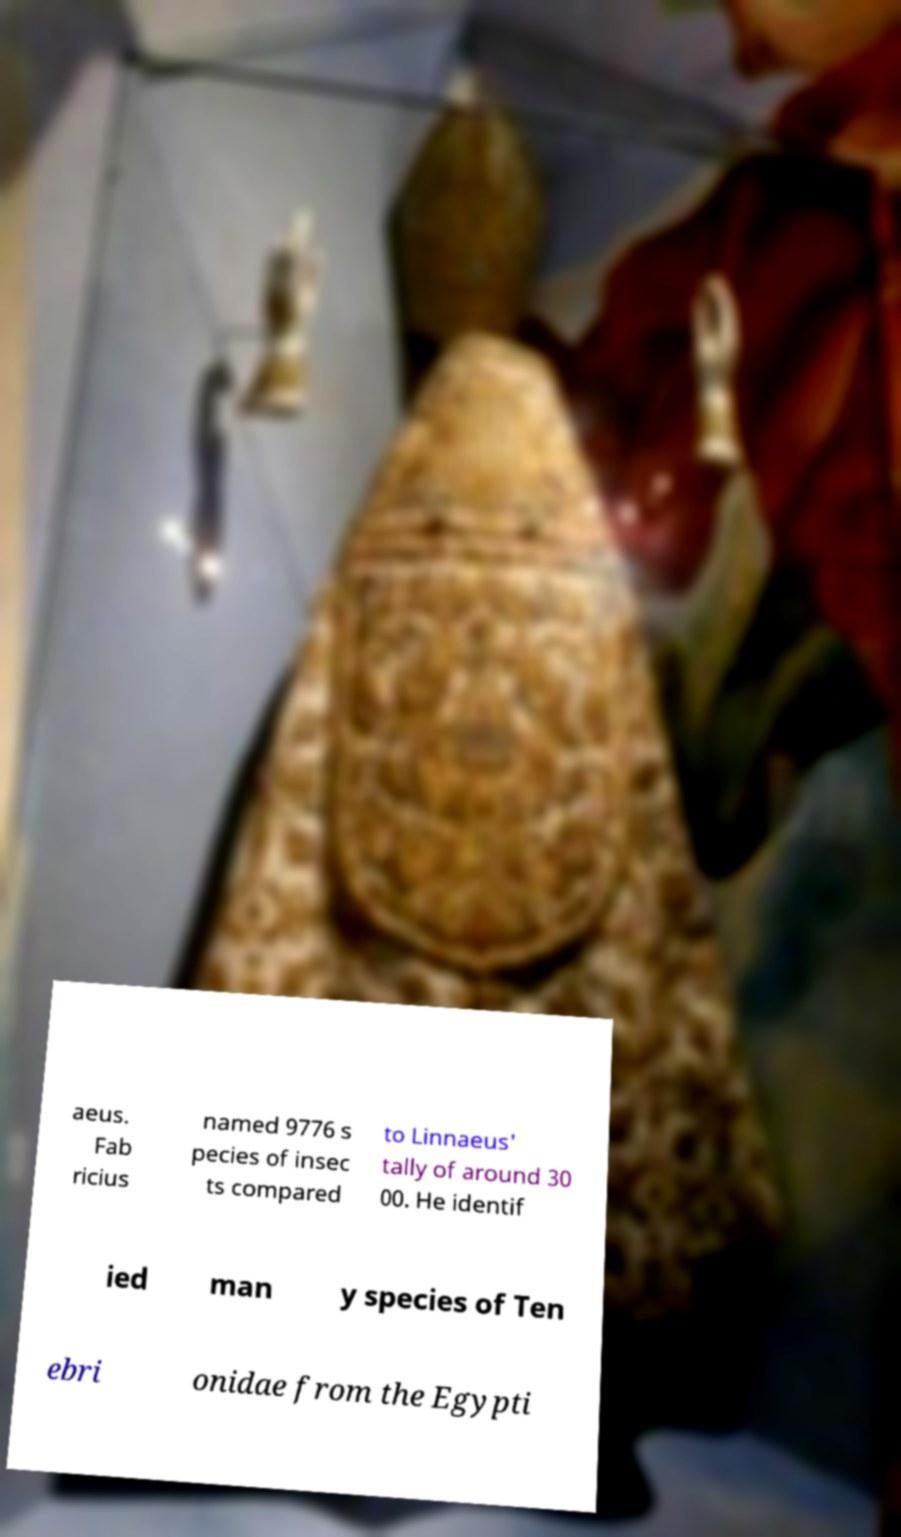Can you read and provide the text displayed in the image?This photo seems to have some interesting text. Can you extract and type it out for me? aeus. Fab ricius named 9776 s pecies of insec ts compared to Linnaeus' tally of around 30 00. He identif ied man y species of Ten ebri onidae from the Egypti 